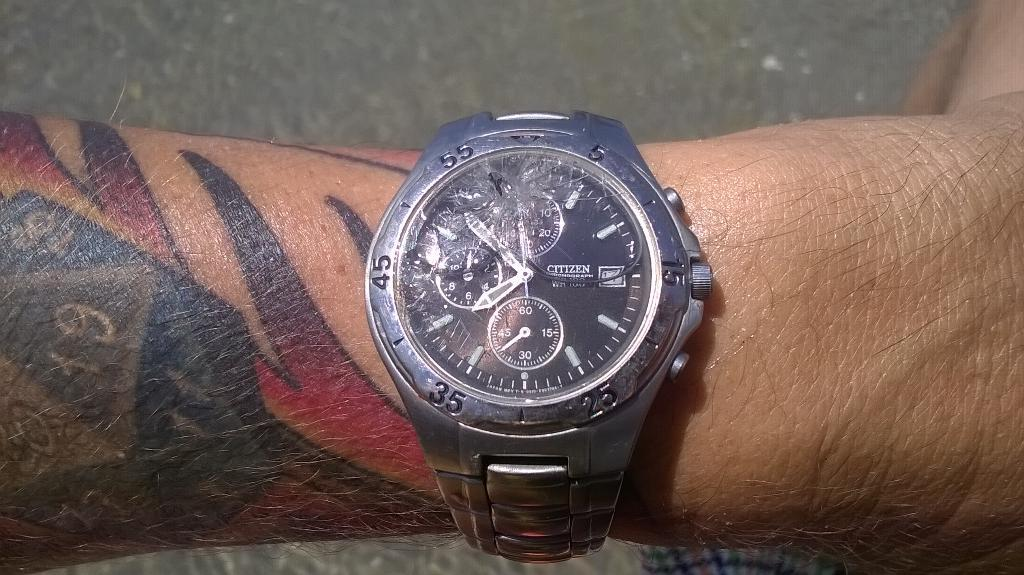<image>
Provide a brief description of the given image. A wrist with a Citizen watch on it 